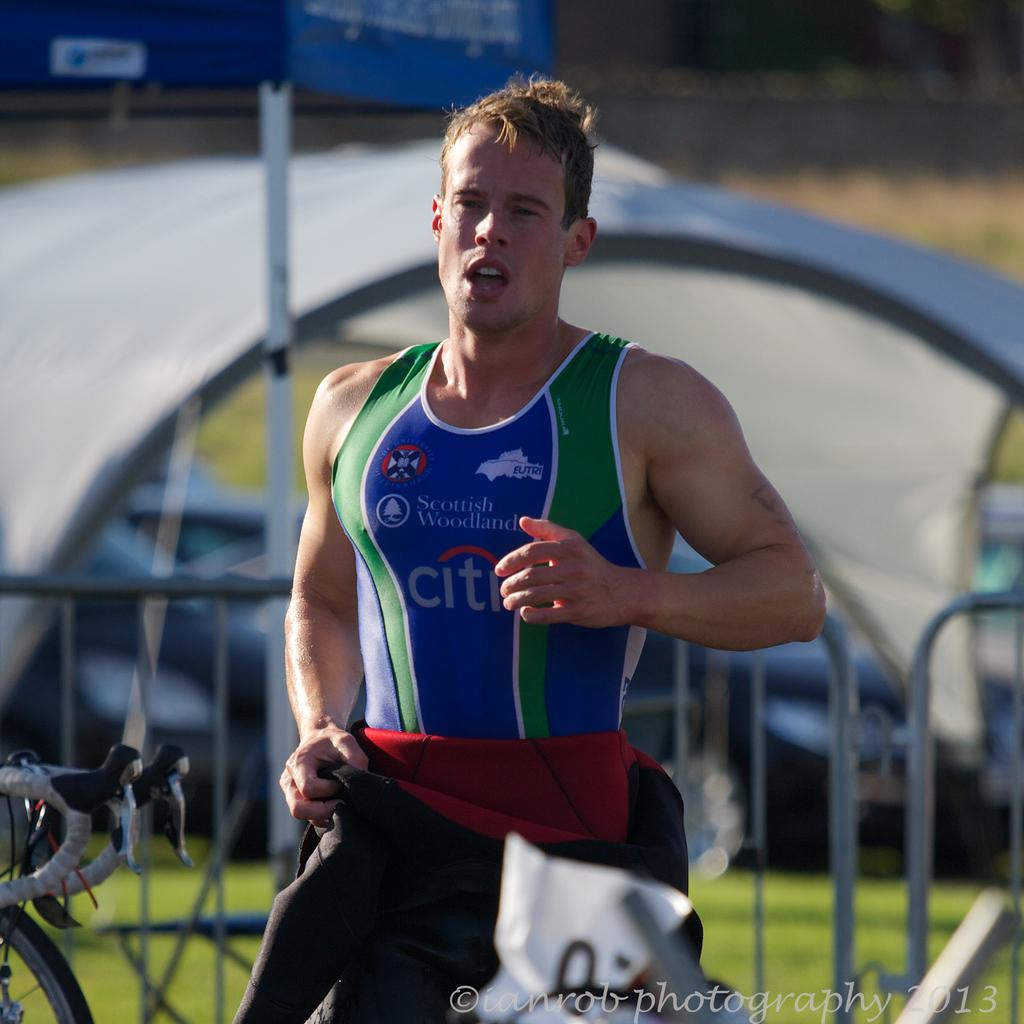<image>
Share a concise interpretation of the image provided. A man is running past a metal fence and his athletic wear says citi and Scottish Woodland. 